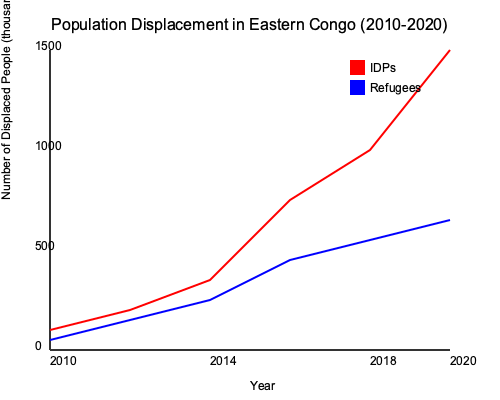Based on the line graph showing population displacement trends in Eastern Congo from 2010 to 2020, what can be concluded about the relationship between the number of Internally Displaced Persons (IDPs) and refugees over time? To analyze the relationship between IDPs and refugees over time, we need to examine the trends of both lines:

1. IDPs (red line):
   - Starts at a lower point in 2010
   - Shows a gradual increase from 2010 to 2014
   - Experiences a sharp increase from 2014 to 2020
   - Ends at the highest point in 2020

2. Refugees (blue line):
   - Starts slightly higher than IDPs in 2010
   - Shows a gradual decrease from 2010 to 2020
   - Ends at a lower point compared to its starting position

3. Comparison:
   - In 2010, the number of refugees was slightly higher than IDPs
   - Around 2014-2015, the lines intersect, indicating an equal number of IDPs and refugees
   - After 2015, the number of IDPs surpasses refugees and continues to increase rapidly
   - By 2020, there is a significant gap between IDPs and refugees, with IDPs being much higher

4. Conclusion:
   The graph shows a diverging trend between IDPs and refugees. While the number of IDPs increased dramatically, especially after 2014, the number of refugees slightly decreased over the same period. This suggests that the conflict in Eastern Congo has led to more internal displacement rather than cross-border movement.
Answer: Diverging trend: IDPs increased dramatically while refugees slightly decreased, indicating more internal displacement than cross-border movement. 